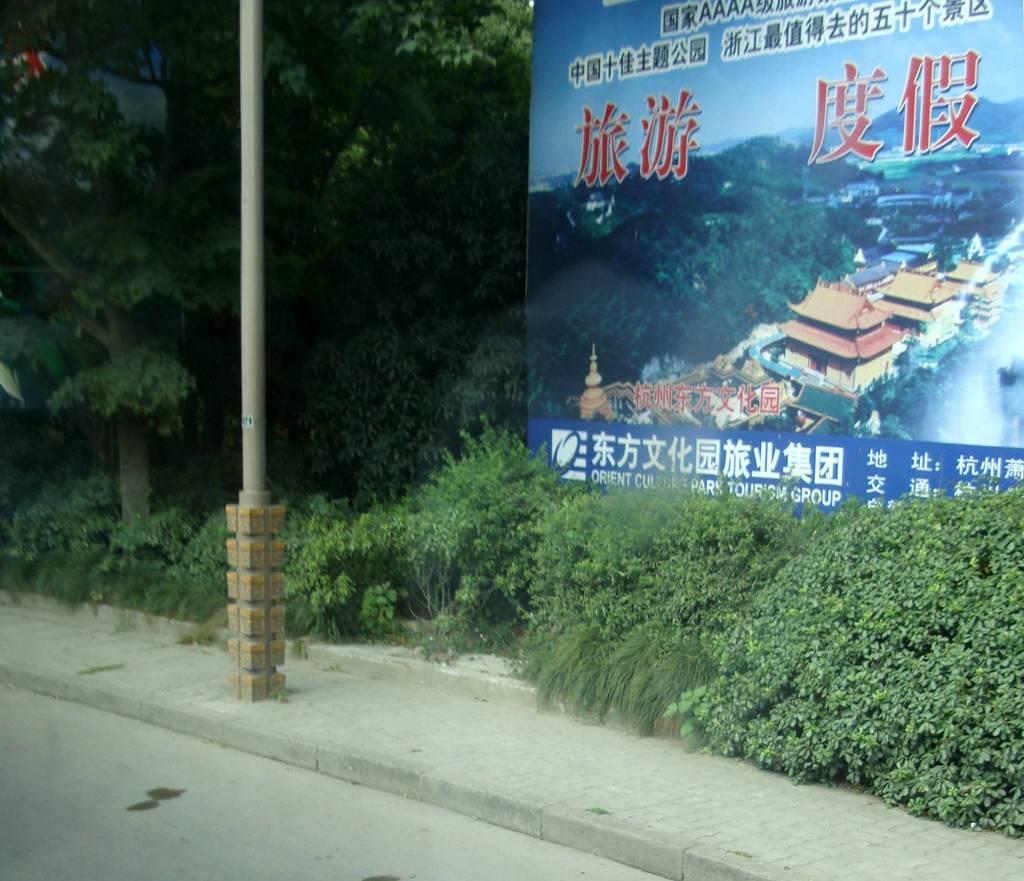How would you summarize this image in a sentence or two? At the bottom we can see road and there is a pole on the footpath and we can see trees and plants on the ground and there is a hoarding on the right side. There is an object on the left side at the top corner. 